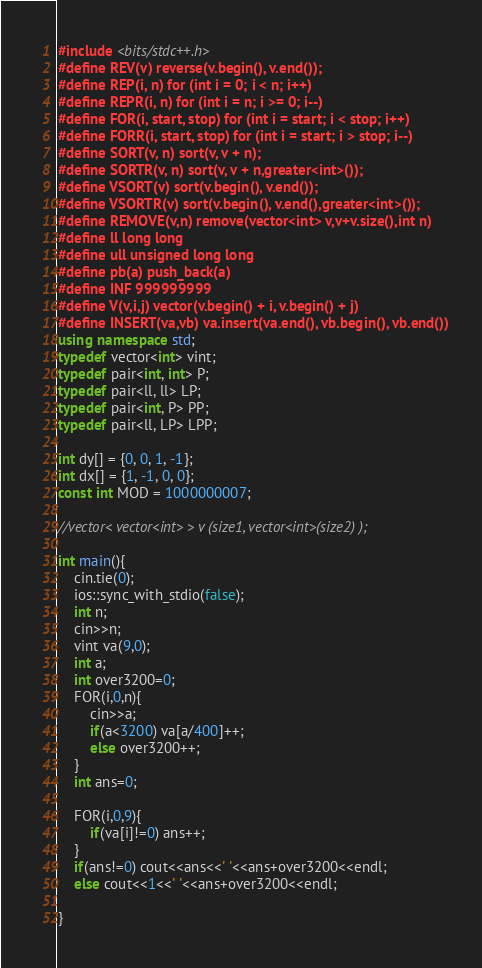Convert code to text. <code><loc_0><loc_0><loc_500><loc_500><_C++_>#include <bits/stdc++.h>
#define REV(v) reverse(v.begin(), v.end());
#define REP(i, n) for (int i = 0; i < n; i++)
#define REPR(i, n) for (int i = n; i >= 0; i--)
#define FOR(i, start, stop) for (int i = start; i < stop; i++)
#define FORR(i, start, stop) for (int i = start; i > stop; i--)
#define SORT(v, n) sort(v, v + n);
#define SORTR(v, n) sort(v, v + n,greater<int>());
#define VSORT(v) sort(v.begin(), v.end());
#define VSORTR(v) sort(v.begin(), v.end(),greater<int>());
#define REMOVE(v,n) remove(vector<int> v,v+v.size(),int n)
#define ll long long
#define ull unsigned long long
#define pb(a) push_back(a)
#define INF 999999999
#define V(v,i,j) vector(v.begin() + i, v.begin() + j)
#define INSERT(va,vb) va.insert(va.end(), vb.begin(), vb.end())
using namespace std;
typedef vector<int> vint;
typedef pair<int, int> P;
typedef pair<ll, ll> LP;
typedef pair<int, P> PP;
typedef pair<ll, LP> LPP;

int dy[] = {0, 0, 1, -1};
int dx[] = {1, -1, 0, 0};
const int MOD = 1000000007;

//vector< vector<int> > v (size1, vector<int>(size2) );

int main(){
    cin.tie(0);
    ios::sync_with_stdio(false);
    int n;
    cin>>n;
    vint va(9,0);
    int a;
    int over3200=0;
    FOR(i,0,n){
        cin>>a;
        if(a<3200) va[a/400]++;
        else over3200++;
    }
    int ans=0;
    
    FOR(i,0,9){
        if(va[i]!=0) ans++;
    }
    if(ans!=0) cout<<ans<<' '<<ans+over3200<<endl;
    else cout<<1<<' '<<ans+over3200<<endl;
	
}</code> 